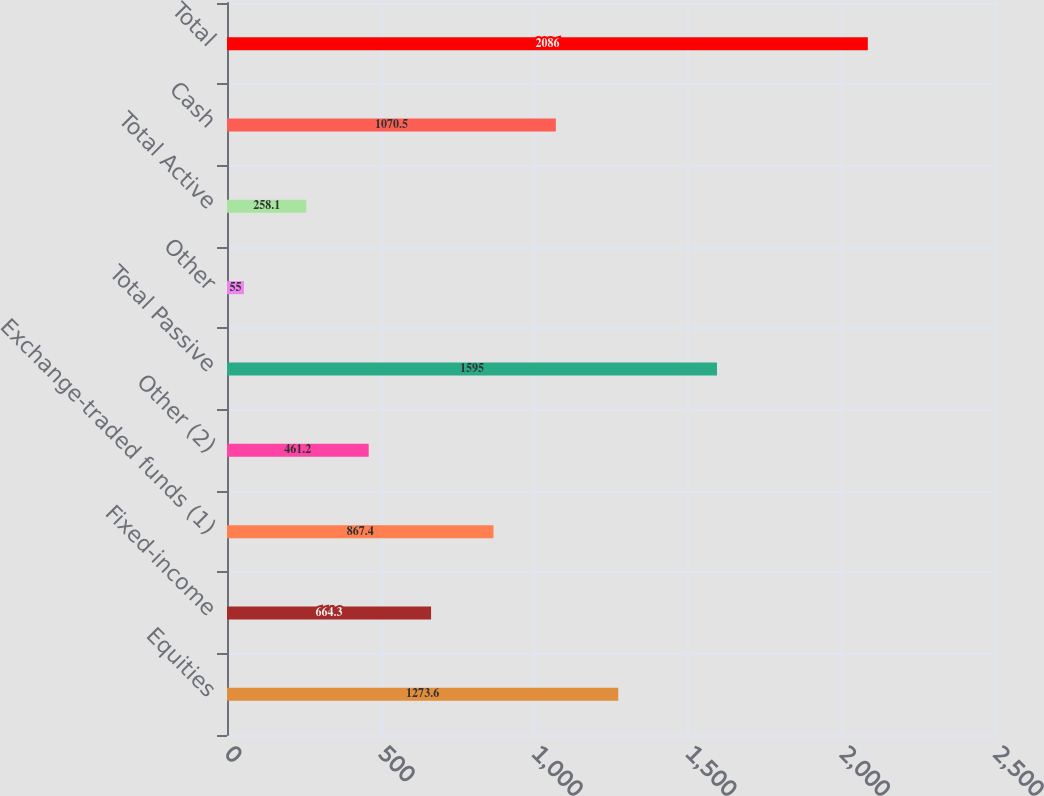<chart> <loc_0><loc_0><loc_500><loc_500><bar_chart><fcel>Equities<fcel>Fixed-income<fcel>Exchange-traded funds (1)<fcel>Other (2)<fcel>Total Passive<fcel>Other<fcel>Total Active<fcel>Cash<fcel>Total<nl><fcel>1273.6<fcel>664.3<fcel>867.4<fcel>461.2<fcel>1595<fcel>55<fcel>258.1<fcel>1070.5<fcel>2086<nl></chart> 